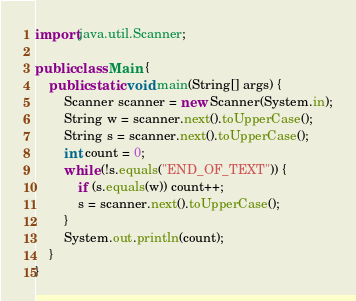<code> <loc_0><loc_0><loc_500><loc_500><_Java_>import java.util.Scanner;

public class Main {
    public static void main(String[] args) {
        Scanner scanner = new Scanner(System.in);
        String w = scanner.next().toUpperCase();
        String s = scanner.next().toUpperCase();
        int count = 0;
        while (!s.equals("END_OF_TEXT")) {
            if (s.equals(w)) count++;
            s = scanner.next().toUpperCase();
        }
        System.out.println(count);
    }
}
</code> 